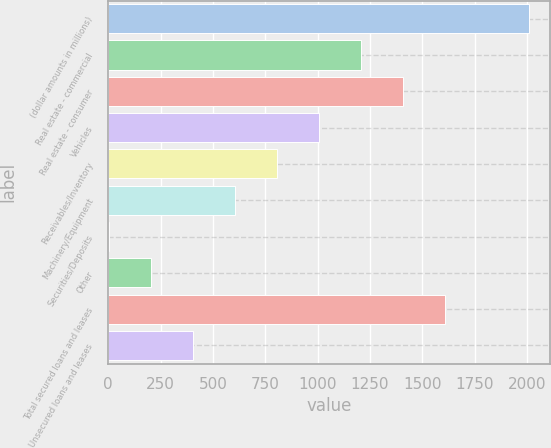<chart> <loc_0><loc_0><loc_500><loc_500><bar_chart><fcel>(dollar amounts in millions)<fcel>Real estate - commercial<fcel>Real estate - consumer<fcel>Vehicles<fcel>Receivables/Inventory<fcel>Machinery/Equipment<fcel>Securities/Deposits<fcel>Other<fcel>Total secured loans and leases<fcel>Unsecured loans and leases<nl><fcel>2010<fcel>1206.8<fcel>1407.6<fcel>1006<fcel>805.2<fcel>604.4<fcel>2<fcel>202.8<fcel>1608.4<fcel>403.6<nl></chart> 